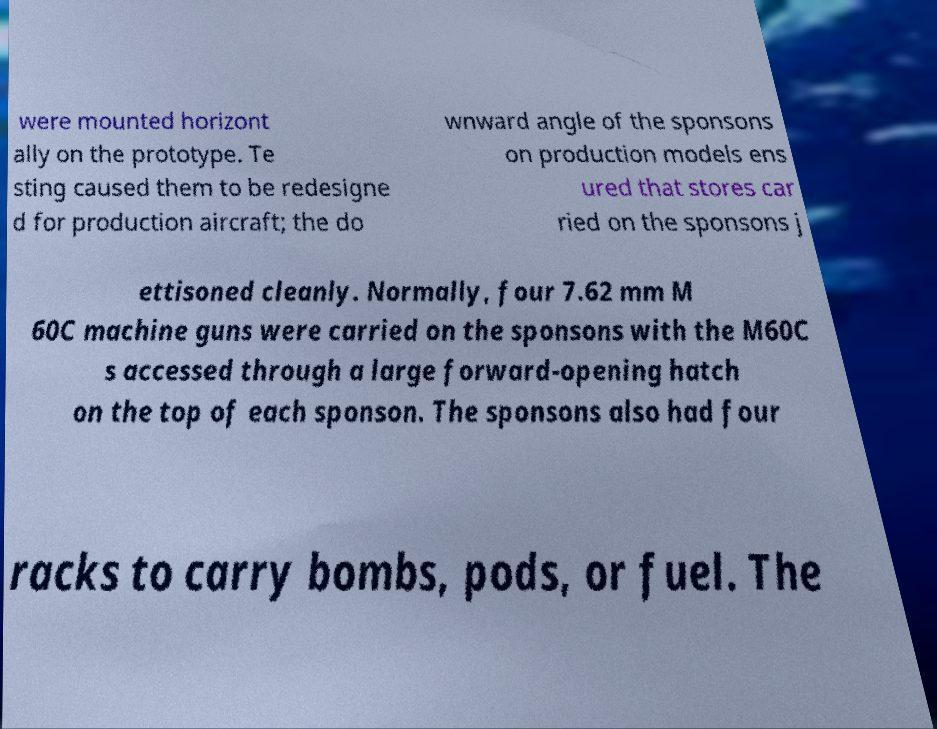Please identify and transcribe the text found in this image. were mounted horizont ally on the prototype. Te sting caused them to be redesigne d for production aircraft; the do wnward angle of the sponsons on production models ens ured that stores car ried on the sponsons j ettisoned cleanly. Normally, four 7.62 mm M 60C machine guns were carried on the sponsons with the M60C s accessed through a large forward-opening hatch on the top of each sponson. The sponsons also had four racks to carry bombs, pods, or fuel. The 